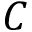Convert formula to latex. <formula><loc_0><loc_0><loc_500><loc_500>C</formula> 